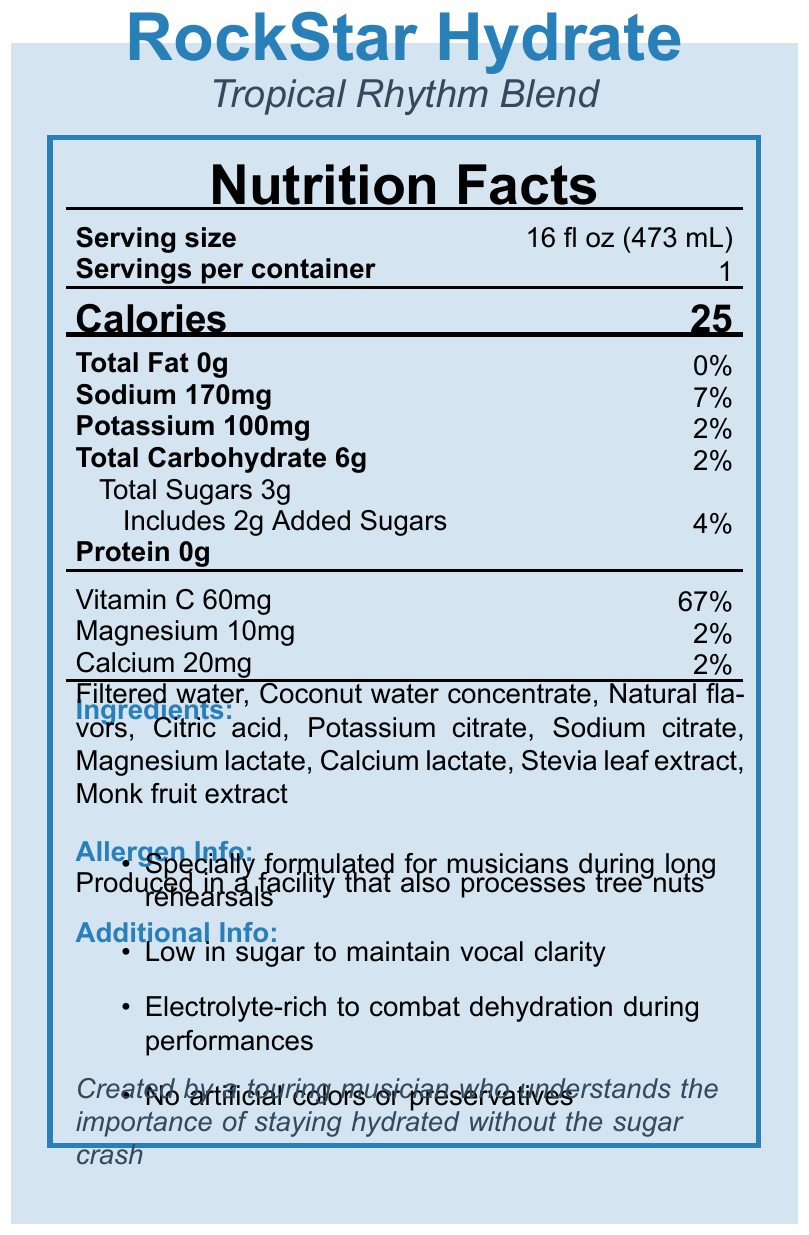what is the product name? The product name is clearly listed as "RockStar Hydrate" at the top of the document.
Answer: RockStar Hydrate what is the serving size? The serving size is stated as "16 fl oz (473 mL)" next to the "Serving size" label.
Answer: 16 fl oz (473 mL) how many calories are there per serving? The document states "Calories 25" just below the serving size information.
Answer: 25 what are the total sugars per serving? Under "Total Carbohydrate," it is specified that there are 3g of Total Sugars.
Answer: 3g what is the sodium content per serving? The sodium content per serving is noted as "Sodium 170mg" in the nutrients section.
Answer: 170mg which of the following is an ingredient in RockStar Hydrate? A. Sugar B. Coconut water concentrate C. Red dye No. 40 D. Aspartame The ingredients list includes "Coconut water concentrate," but not the other options.
Answer: B. Coconut water concentrate how much Vitamin C does one serving provide? A. 30mg B. 60mg C. 100mg D. 120mg The document specifies "Vitamin C 60mg" in the Vitamins and Minerals section.
Answer: B. 60mg is there any added sugar in this sports drink? The nutrients section shows "Includes 2g Added Sugars."
Answer: Yes what is the primary purpose of this sports drink? The additional info mentions it is "specially formulated for musicians during long rehearsals."
Answer: Hydration for musicians during long rehearsals does RockStar Hydrate contain any artificial preservatives? The document specifically states "No artificial colors or preservatives."
Answer: No who created RockStar Hydrate? The brand story mentions it was "created by a touring musician."
Answer: A touring musician what type of flavor does RockStar Hydrate have? The flavor is listed as "Tropical Rhythm Blend" under the product name.
Answer: Tropical Rhythm Blend where is this product produced in relation to allergens? The allergen information states that it is "Produced in a facility that also processes tree nuts."
Answer: In a facility that also processes tree nuts list three minerals contained in RockStar Hydrate and their amounts? These minerals and their amounts are listed in the nutrients and vitamins/minerals section.
Answer: Sodium 170mg, Potassium 100mg, Magnesium 10mg can the total protein content be improved? The document only states the current protein content; it doesn't provide data on potential improvements.
Answer: Not enough information summarize the main benefits of RockStar Hydrate. The additional info section highlights these main benefits.
Answer: Specially formulated for musicians during long rehearsals, low in sugar, electrolyte-rich, no artificial colors or preservatives describe the appearance of the document The background, colors, and layout details suggest an organized and visually appealing document.
Answer: The document uses a colorful design with a blue and gray color scheme. The product name is prominently displayed at the top, followed by various sections such as nutrition facts, ingredients, allergen info, additional info, and a brand story. how many servings are in each container of RockStar Hydrate? It is clearly stated that there is "1" serving per container.
Answer: 1 what makes this product suitable for vocal clarity? The additional info mentions that it is "low in sugar to maintain vocal clarity."
Answer: Low in sugar what is the recommended use for this sports drink? The document under "recommended use" states to "consume before and during band rehearsals or performances."
Answer: Consume before and during band rehearsals or performances 